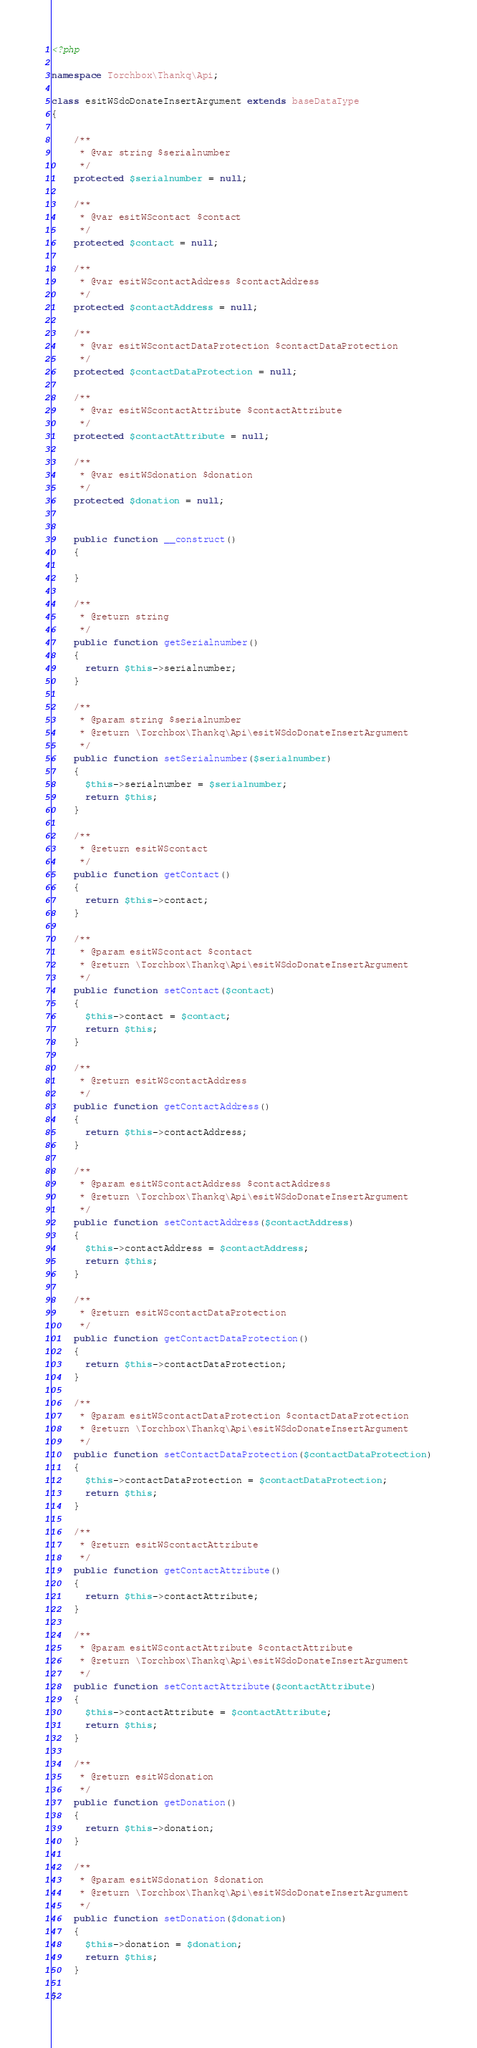<code> <loc_0><loc_0><loc_500><loc_500><_PHP_><?php

namespace Torchbox\Thankq\Api;

class esitWSdoDonateInsertArgument extends baseDataType
{

    /**
     * @var string $serialnumber
     */
    protected $serialnumber = null;

    /**
     * @var esitWScontact $contact
     */
    protected $contact = null;

    /**
     * @var esitWScontactAddress $contactAddress
     */
    protected $contactAddress = null;

    /**
     * @var esitWScontactDataProtection $contactDataProtection
     */
    protected $contactDataProtection = null;

    /**
     * @var esitWScontactAttribute $contactAttribute
     */
    protected $contactAttribute = null;

    /**
     * @var esitWSdonation $donation
     */
    protected $donation = null;

    
    public function __construct()
    {
    
    }

    /**
     * @return string
     */
    public function getSerialnumber()
    {
      return $this->serialnumber;
    }

    /**
     * @param string $serialnumber
     * @return \Torchbox\Thankq\Api\esitWSdoDonateInsertArgument
     */
    public function setSerialnumber($serialnumber)
    {
      $this->serialnumber = $serialnumber;
      return $this;
    }

    /**
     * @return esitWScontact
     */
    public function getContact()
    {
      return $this->contact;
    }

    /**
     * @param esitWScontact $contact
     * @return \Torchbox\Thankq\Api\esitWSdoDonateInsertArgument
     */
    public function setContact($contact)
    {
      $this->contact = $contact;
      return $this;
    }

    /**
     * @return esitWScontactAddress
     */
    public function getContactAddress()
    {
      return $this->contactAddress;
    }

    /**
     * @param esitWScontactAddress $contactAddress
     * @return \Torchbox\Thankq\Api\esitWSdoDonateInsertArgument
     */
    public function setContactAddress($contactAddress)
    {
      $this->contactAddress = $contactAddress;
      return $this;
    }

    /**
     * @return esitWScontactDataProtection
     */
    public function getContactDataProtection()
    {
      return $this->contactDataProtection;
    }

    /**
     * @param esitWScontactDataProtection $contactDataProtection
     * @return \Torchbox\Thankq\Api\esitWSdoDonateInsertArgument
     */
    public function setContactDataProtection($contactDataProtection)
    {
      $this->contactDataProtection = $contactDataProtection;
      return $this;
    }

    /**
     * @return esitWScontactAttribute
     */
    public function getContactAttribute()
    {
      return $this->contactAttribute;
    }

    /**
     * @param esitWScontactAttribute $contactAttribute
     * @return \Torchbox\Thankq\Api\esitWSdoDonateInsertArgument
     */
    public function setContactAttribute($contactAttribute)
    {
      $this->contactAttribute = $contactAttribute;
      return $this;
    }

    /**
     * @return esitWSdonation
     */
    public function getDonation()
    {
      return $this->donation;
    }

    /**
     * @param esitWSdonation $donation
     * @return \Torchbox\Thankq\Api\esitWSdoDonateInsertArgument
     */
    public function setDonation($donation)
    {
      $this->donation = $donation;
      return $this;
    }

}
</code> 